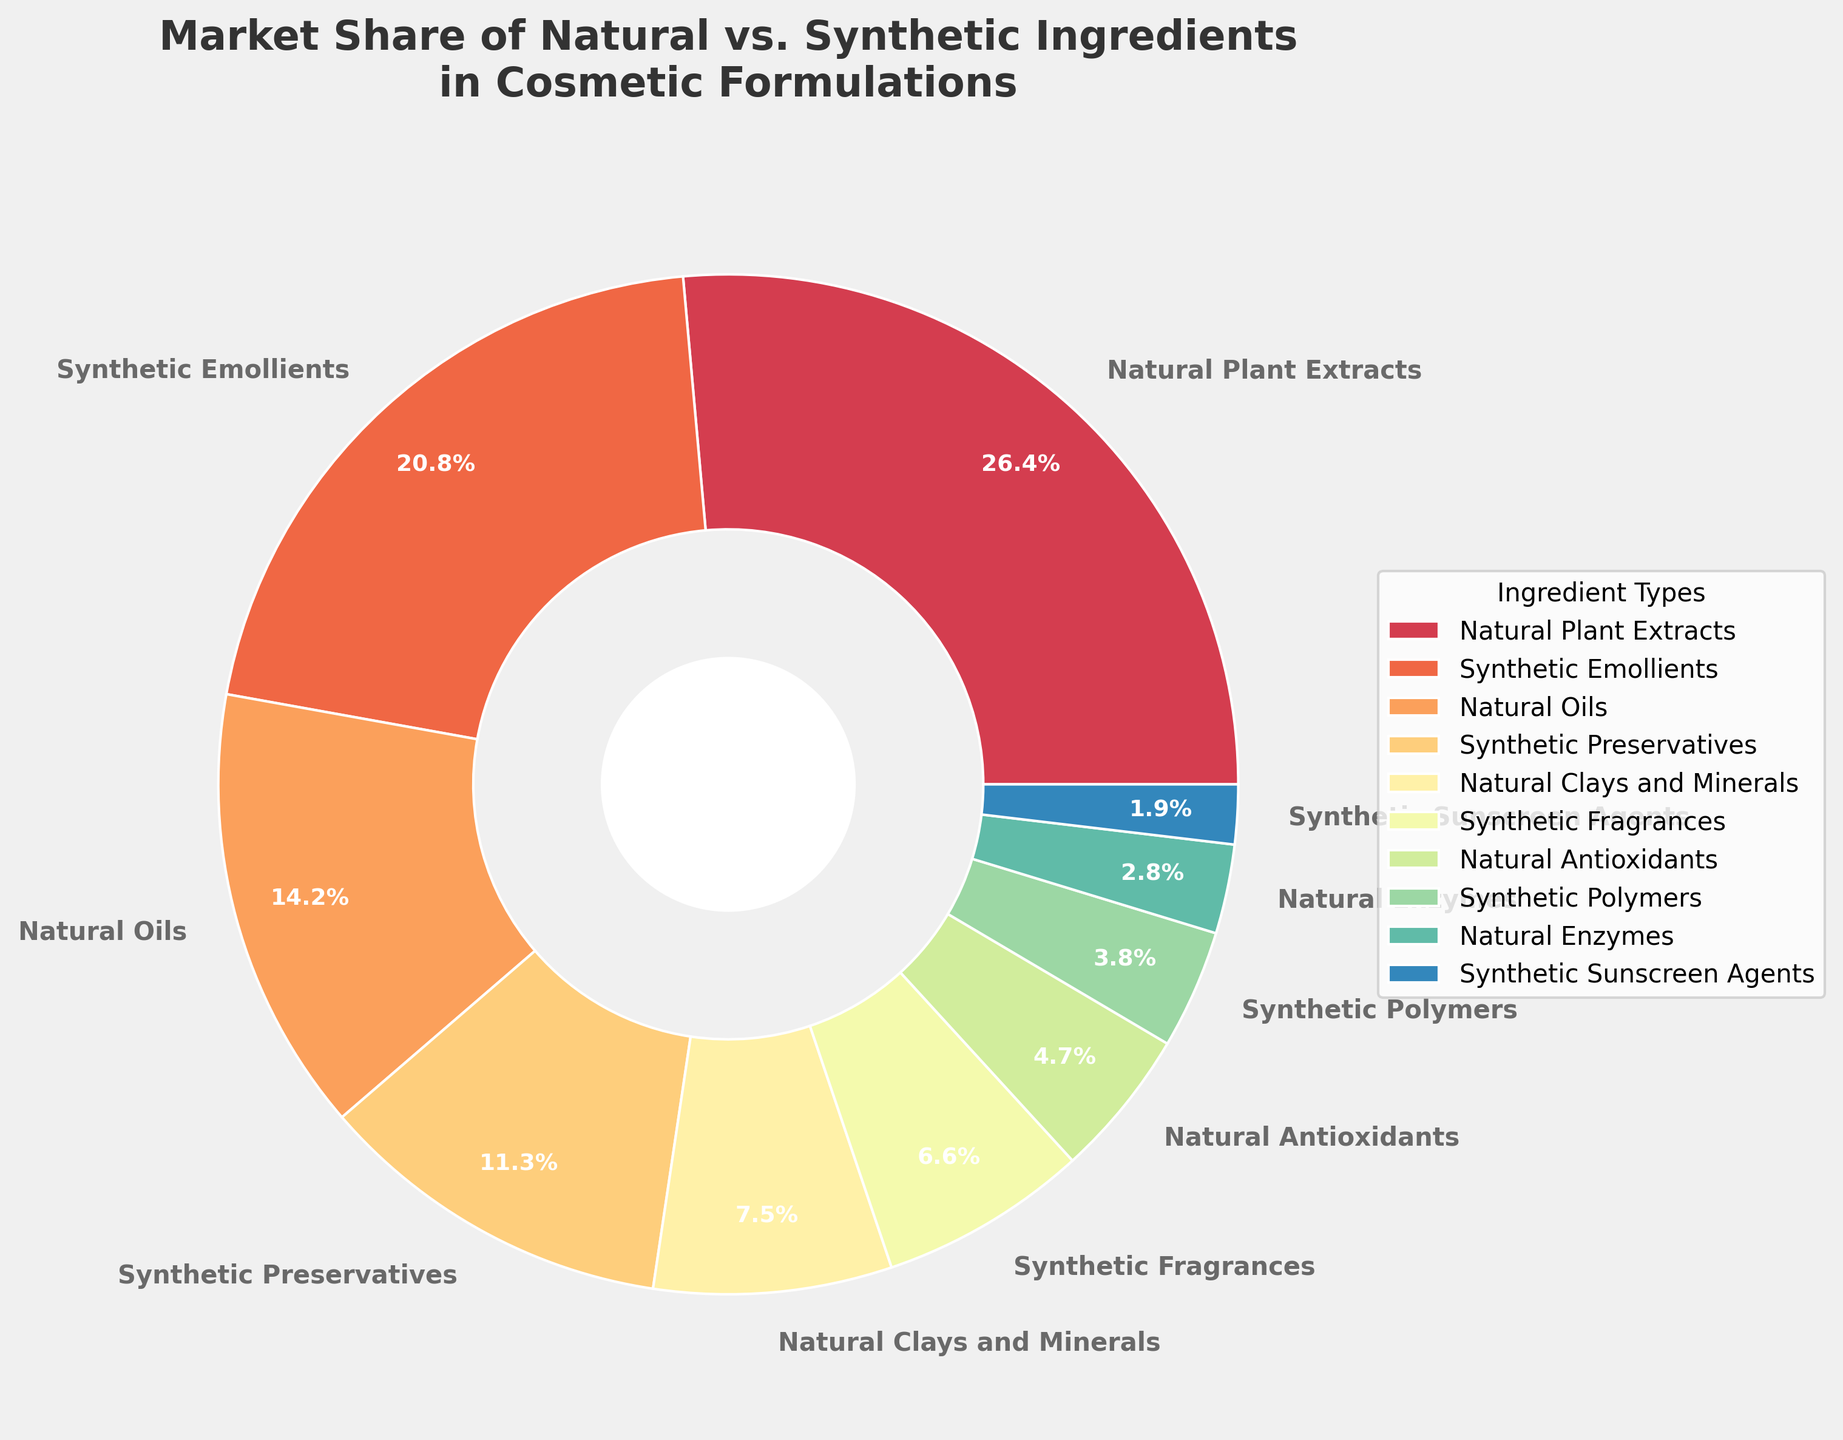What's the combined market share percentage of all natural ingredients? Sum the market share percentages of all natural ingredients: Natural Plant Extracts (28%) + Natural Oils (15%) + Natural Clays and Minerals (8%) + Natural Antioxidants (5%) + Natural Enzymes (3%). The sum is 28 + 15 + 8 + 5 + 3 = 59%.
Answer: 59% Which ingredient type has the largest market share? Identify the wedge with the highest percentage from the pie chart. The largest market share is shown for 'Natural Plant Extracts' with 28%.
Answer: Natural Plant Extracts Are synthetic ingredients' aggregate market shares greater than natural ingredients'? Sum the market shares of synthetic ingredients: Synthetic Emollients (22%) + Synthetic Preservatives (12%) + Synthetic Fragrances (7%) + Synthetic Polymers (4%) + Synthetic Sunscreen Agents (2%) = 22 + 12 + 7 + 4 + 2 = 47%. Compare this with the sum of natural ingredients, which is 59%. 47% is less than 59%.
Answer: No Which has a smaller market share, Synthetic Fragrances or Natural Clays and Minerals? Directly compare the market share percentages of Synthetic Fragrances (7%) and Natural Clays and Minerals (8%). Synthetic Fragrances have a smaller market share.
Answer: Synthetic Fragrances Which type of ingredient (natural or synthetic) has more variations in the pie chart? Count the number of natural and synthetic ingredient types presented in the chart. There are 5 natural (Natural Plant Extracts, Natural Oils, Natural Clays and Minerals, Natural Antioxidants, Natural Enzymes) and 5 synthetic (Synthetic Emollients, Synthetic Preservatives, Synthetic Fragrances, Synthetic Polymers, Synthetic Sunscreen Agents) ingredients.
Answer: Both have equal variations What’s the market share difference between the largest and smallest segments? Identify the largest segment (Natural Plant Extracts: 28%) and the smallest segment (Synthetic Sunscreen Agents: 2%). Find the difference: 28 - 2 = 26%.
Answer: 26% Which synthetic ingredient has the second highest market share? List the market shares of synthetic ingredients and find the second highest value: Synthetic Emollients (22%), Synthetic Preservatives (12%), Synthetic Fragrances (7%), Synthetic Polymers (4%), Synthetic Sunscreen Agents (2%). The second highest is Synthetic Preservatives with 12%.
Answer: Synthetic Preservatives How much less market share do Natural Enzymes have compared to Natural Plant Extracts? Find the market shares of Natural Enzymes (3%) and Natural Plant Extracts (28%). Subtract the market share of Natural Enzymes from that of Natural Plant Extracts: 28 - 3 = 25%.
Answer: 25% What color is associated with the ingredient type having the least market share? Visually identify the color corresponding to the Synthetic Sunscreen Agents segment, which has the smallest market share of 2%. This would involve checking the chart but assuming it is consistent with the color scheme in data, it should be one of the lighter or distinct colors at the end of the spectrum.
Answer: Lightest color (likely a pale/light version of a color shown) 